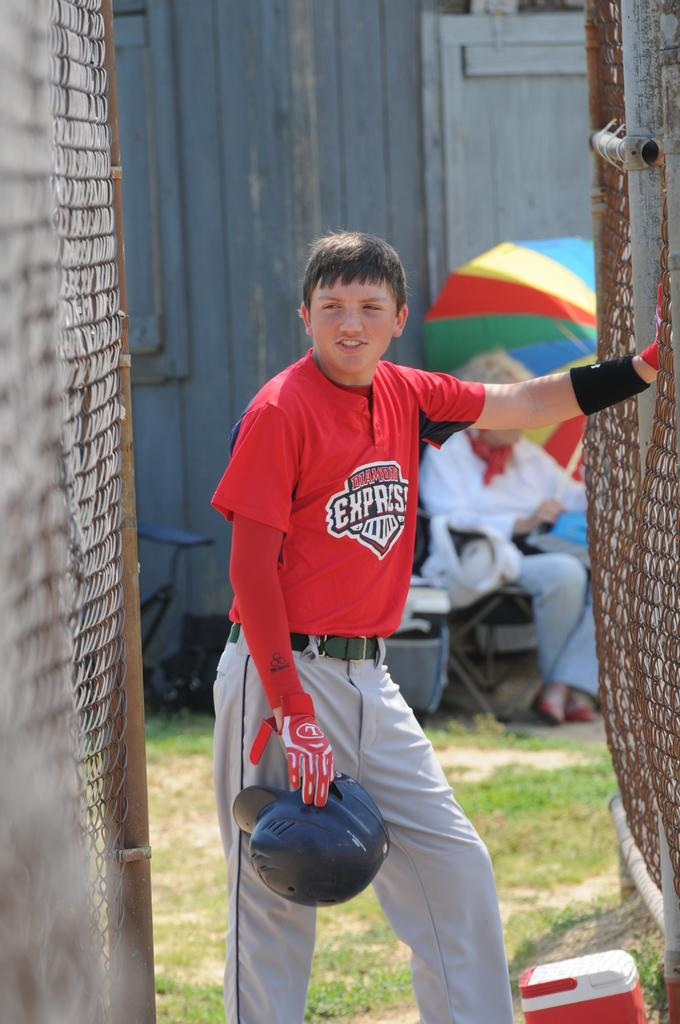Provide a one-sentence caption for the provided image. A baseball player holding his helmet wearing a read Diamond Express jersey with a lady under an umbrella in the background. 